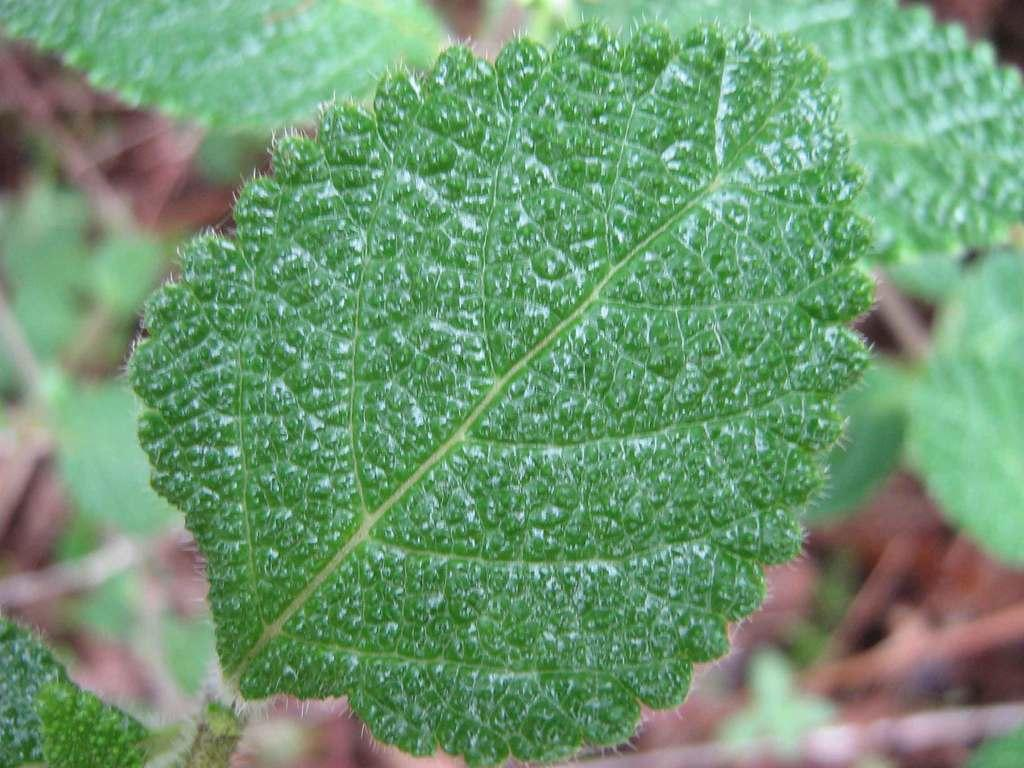What is the main subject of the image? The main subject of the image is a leaf. What can be inferred about the leaf in the image? The leaf belongs to a plant. What else can be seen in the image besides the leaf? There are other leaves visible in the background of the image. Can you describe the door in the image? There is no door present in the image; it is a zoomed-in picture of a leaf. What type of vehicle is the person driving in the image? There is no person or vehicle present in the image; it is a close-up of a leaf. 